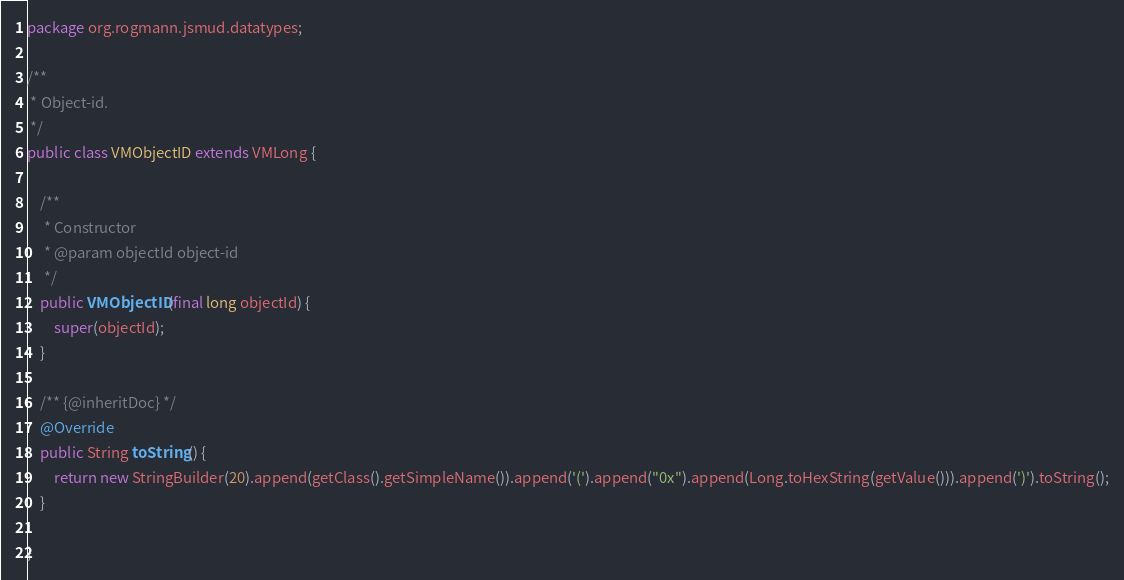Convert code to text. <code><loc_0><loc_0><loc_500><loc_500><_Java_>package org.rogmann.jsmud.datatypes;

/**
 * Object-id.
 */
public class VMObjectID extends VMLong {

	/**
	 * Constructor
	 * @param objectId object-id
	 */
	public VMObjectID(final long objectId) {
		super(objectId);
	}

	/** {@inheritDoc} */
	@Override
	public String toString() {
		return new StringBuilder(20).append(getClass().getSimpleName()).append('(').append("0x").append(Long.toHexString(getValue())).append(')').toString();
	}

}
</code> 